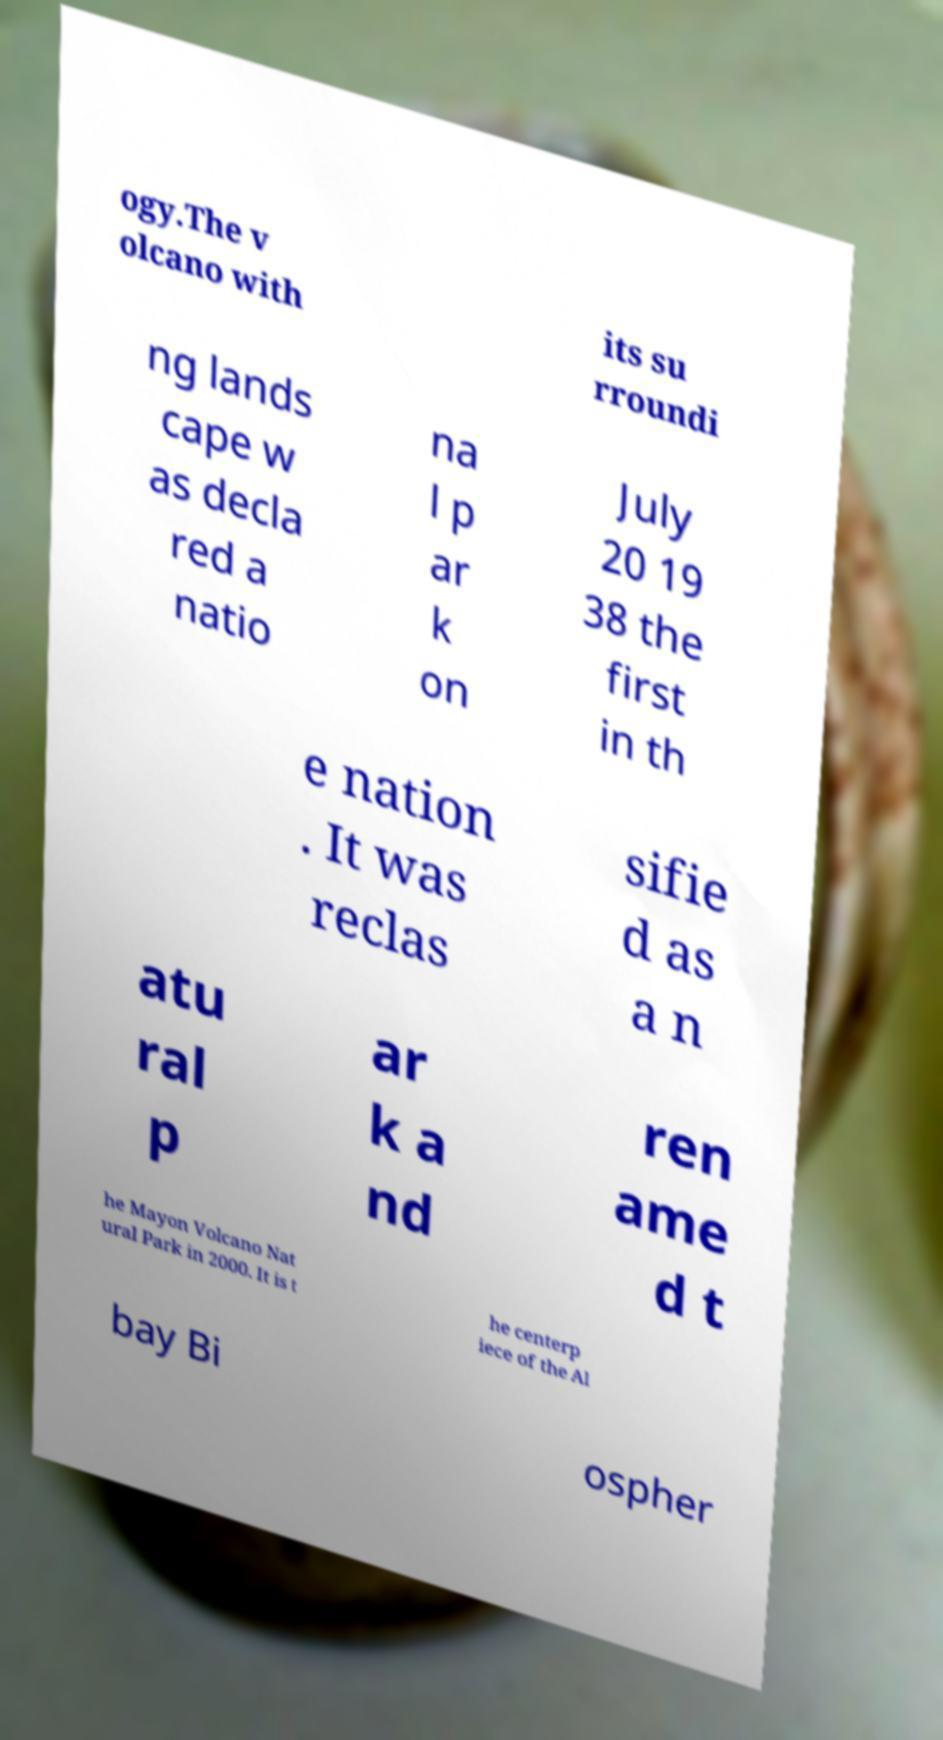Can you read and provide the text displayed in the image?This photo seems to have some interesting text. Can you extract and type it out for me? ogy.The v olcano with its su rroundi ng lands cape w as decla red a natio na l p ar k on July 20 19 38 the first in th e nation . It was reclas sifie d as a n atu ral p ar k a nd ren ame d t he Mayon Volcano Nat ural Park in 2000. It is t he centerp iece of the Al bay Bi ospher 